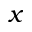Convert formula to latex. <formula><loc_0><loc_0><loc_500><loc_500>x</formula> 